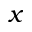Convert formula to latex. <formula><loc_0><loc_0><loc_500><loc_500>x</formula> 